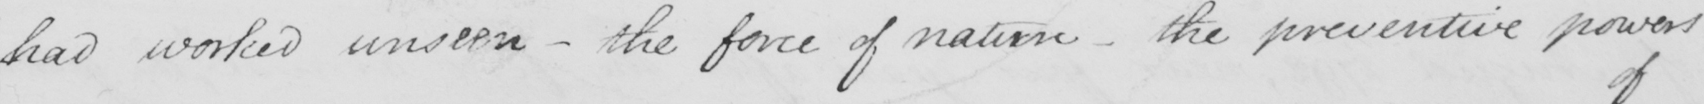What is written in this line of handwriting? had worked unseen  _  the force of nature  _  the preventive powers 